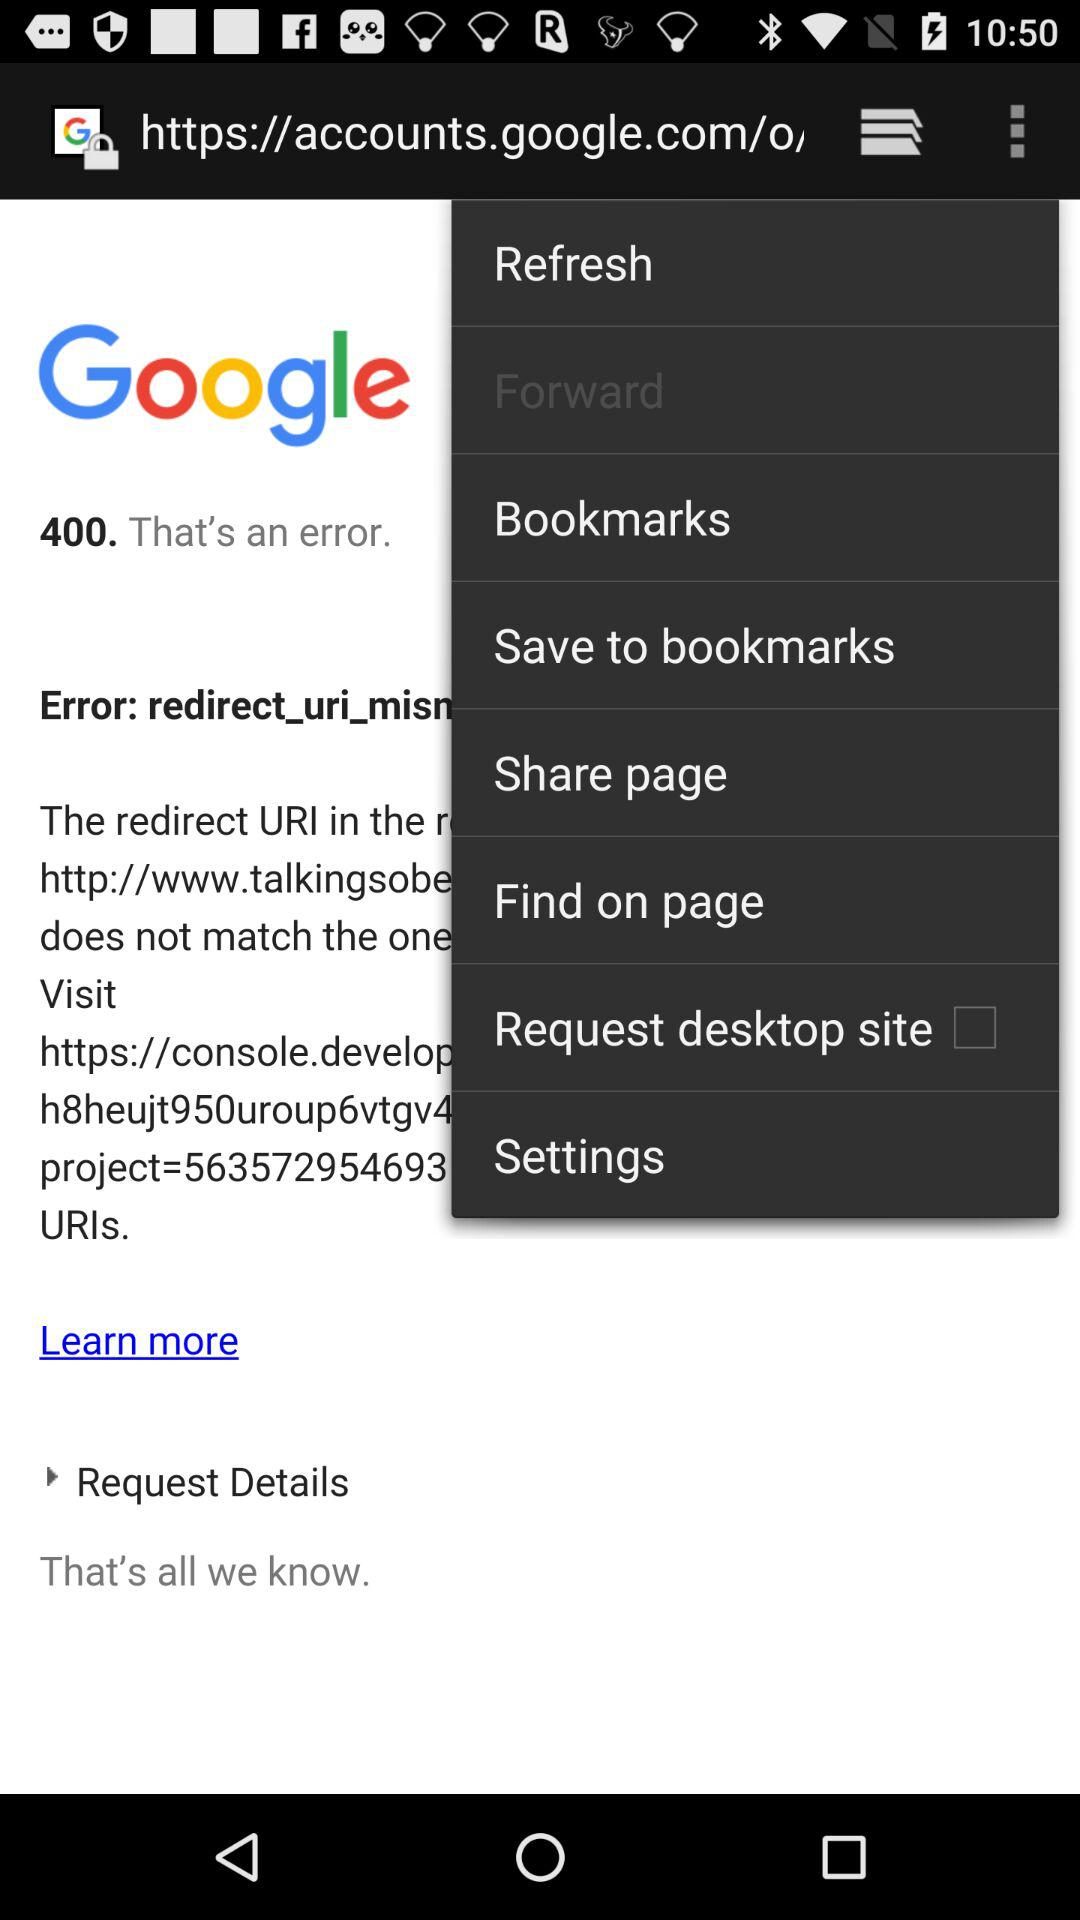What is the status of "Request desktop site"? The status of "Request desktop site" is "off". 